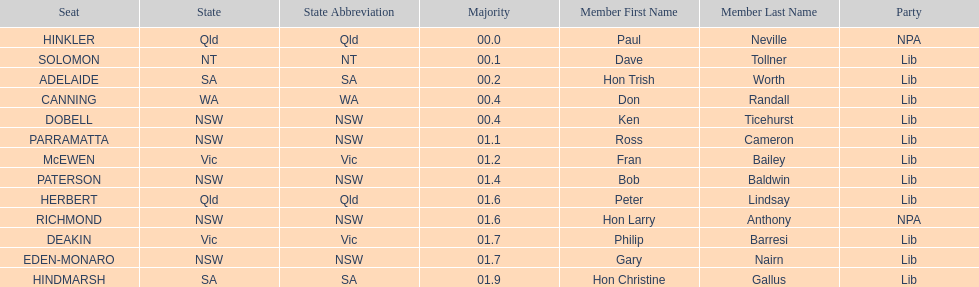How many states were represented in the seats? 6. 